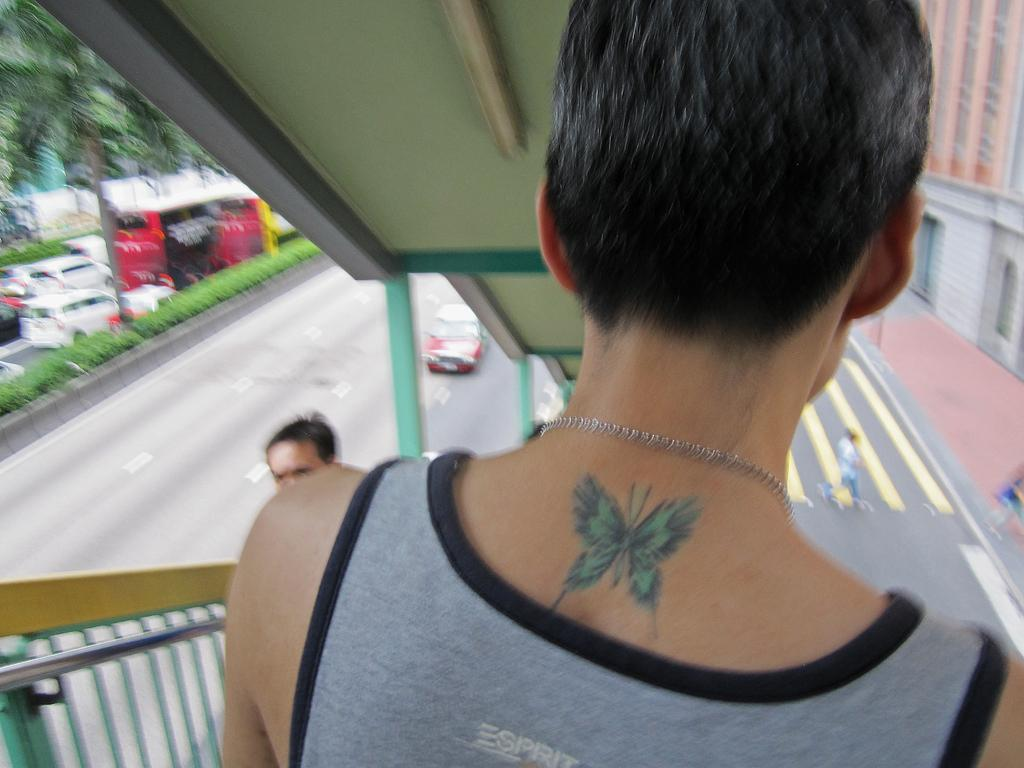What color is the dress worn by the person in the image? The person in the image is wearing an ash and black color dress. Can you describe any additional features of the person's appearance? The person has a tattoo on their body. What else can be seen in the image besides the person? There are vehicles, people, and railing in the image. How would you describe the background of the image? The background of the image is blurred. How many frogs are sitting on the railing in the image? There are no frogs present in the image. What type of net is being used by the people in the image? There is no net visible in the image. 